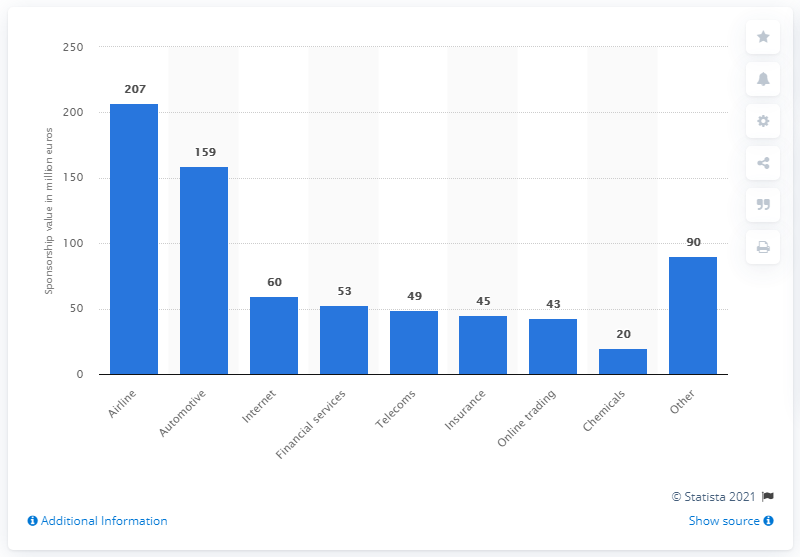Highlight a few significant elements in this photo. The value of shirt sponsorship deals with airline companies in 2019 was 207. In 2019, the automotive industry's shirt sponsorship deals had a value of approximately 159. 